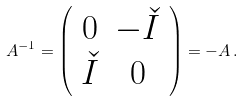Convert formula to latex. <formula><loc_0><loc_0><loc_500><loc_500>{ A } ^ { - 1 } = \left ( \begin{array} { c c } 0 & - \check { I } \\ \check { I } & 0 \end{array} \right ) = - { A } \, .</formula> 